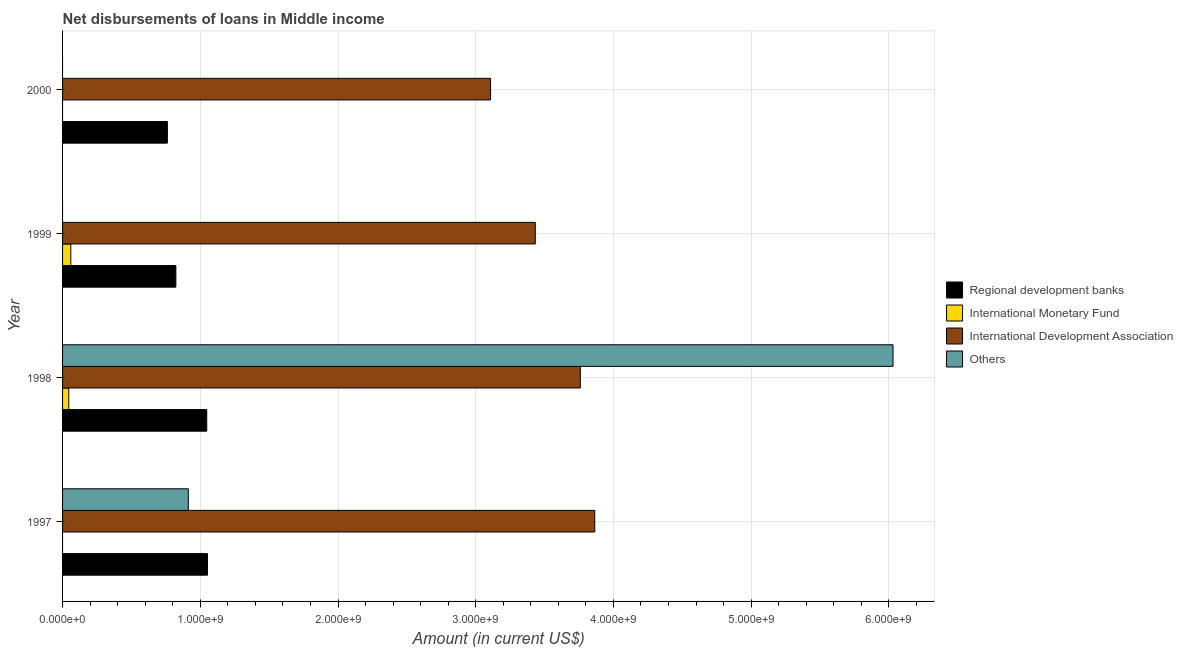How many different coloured bars are there?
Offer a very short reply. 4. How many groups of bars are there?
Provide a short and direct response. 4. Are the number of bars on each tick of the Y-axis equal?
Ensure brevity in your answer.  No. How many bars are there on the 1st tick from the top?
Your answer should be very brief. 2. What is the label of the 1st group of bars from the top?
Keep it short and to the point. 2000. What is the amount of loan disimbursed by regional development banks in 1999?
Offer a terse response. 8.23e+08. Across all years, what is the maximum amount of loan disimbursed by international development association?
Give a very brief answer. 3.86e+09. Across all years, what is the minimum amount of loan disimbursed by regional development banks?
Your answer should be compact. 7.61e+08. In which year was the amount of loan disimbursed by international monetary fund maximum?
Offer a very short reply. 1999. What is the total amount of loan disimbursed by regional development banks in the graph?
Offer a very short reply. 3.68e+09. What is the difference between the amount of loan disimbursed by regional development banks in 1999 and that in 2000?
Give a very brief answer. 6.15e+07. What is the difference between the amount of loan disimbursed by other organisations in 1997 and the amount of loan disimbursed by international development association in 1999?
Offer a very short reply. -2.52e+09. What is the average amount of loan disimbursed by other organisations per year?
Offer a very short reply. 1.74e+09. In the year 1999, what is the difference between the amount of loan disimbursed by international monetary fund and amount of loan disimbursed by regional development banks?
Keep it short and to the point. -7.63e+08. What is the ratio of the amount of loan disimbursed by regional development banks in 1997 to that in 2000?
Your answer should be very brief. 1.38. Is the amount of loan disimbursed by regional development banks in 1999 less than that in 2000?
Ensure brevity in your answer.  No. What is the difference between the highest and the second highest amount of loan disimbursed by international development association?
Your answer should be compact. 1.05e+08. What is the difference between the highest and the lowest amount of loan disimbursed by international monetary fund?
Your answer should be compact. 5.98e+07. Is the sum of the amount of loan disimbursed by regional development banks in 1997 and 1999 greater than the maximum amount of loan disimbursed by international monetary fund across all years?
Provide a short and direct response. Yes. Is it the case that in every year, the sum of the amount of loan disimbursed by regional development banks and amount of loan disimbursed by international monetary fund is greater than the amount of loan disimbursed by international development association?
Provide a short and direct response. No. Are all the bars in the graph horizontal?
Your response must be concise. Yes. How many years are there in the graph?
Your answer should be compact. 4. Are the values on the major ticks of X-axis written in scientific E-notation?
Provide a succinct answer. Yes. Does the graph contain any zero values?
Your answer should be compact. Yes. How are the legend labels stacked?
Keep it short and to the point. Vertical. What is the title of the graph?
Provide a succinct answer. Net disbursements of loans in Middle income. Does "Tracking ability" appear as one of the legend labels in the graph?
Provide a short and direct response. No. What is the label or title of the X-axis?
Ensure brevity in your answer.  Amount (in current US$). What is the Amount (in current US$) of Regional development banks in 1997?
Offer a very short reply. 1.05e+09. What is the Amount (in current US$) of International Development Association in 1997?
Your answer should be compact. 3.86e+09. What is the Amount (in current US$) in Others in 1997?
Your answer should be compact. 9.13e+08. What is the Amount (in current US$) of Regional development banks in 1998?
Ensure brevity in your answer.  1.05e+09. What is the Amount (in current US$) in International Monetary Fund in 1998?
Keep it short and to the point. 4.51e+07. What is the Amount (in current US$) of International Development Association in 1998?
Your response must be concise. 3.76e+09. What is the Amount (in current US$) of Others in 1998?
Keep it short and to the point. 6.03e+09. What is the Amount (in current US$) of Regional development banks in 1999?
Offer a very short reply. 8.23e+08. What is the Amount (in current US$) in International Monetary Fund in 1999?
Your answer should be very brief. 5.98e+07. What is the Amount (in current US$) of International Development Association in 1999?
Ensure brevity in your answer.  3.43e+09. What is the Amount (in current US$) in Regional development banks in 2000?
Offer a very short reply. 7.61e+08. What is the Amount (in current US$) in International Monetary Fund in 2000?
Your answer should be compact. 0. What is the Amount (in current US$) of International Development Association in 2000?
Ensure brevity in your answer.  3.11e+09. Across all years, what is the maximum Amount (in current US$) of Regional development banks?
Your response must be concise. 1.05e+09. Across all years, what is the maximum Amount (in current US$) of International Monetary Fund?
Offer a terse response. 5.98e+07. Across all years, what is the maximum Amount (in current US$) of International Development Association?
Provide a short and direct response. 3.86e+09. Across all years, what is the maximum Amount (in current US$) in Others?
Provide a short and direct response. 6.03e+09. Across all years, what is the minimum Amount (in current US$) of Regional development banks?
Ensure brevity in your answer.  7.61e+08. Across all years, what is the minimum Amount (in current US$) of International Monetary Fund?
Provide a succinct answer. 0. Across all years, what is the minimum Amount (in current US$) in International Development Association?
Make the answer very short. 3.11e+09. Across all years, what is the minimum Amount (in current US$) in Others?
Provide a succinct answer. 0. What is the total Amount (in current US$) in Regional development banks in the graph?
Ensure brevity in your answer.  3.68e+09. What is the total Amount (in current US$) of International Monetary Fund in the graph?
Offer a very short reply. 1.05e+08. What is the total Amount (in current US$) of International Development Association in the graph?
Make the answer very short. 1.42e+1. What is the total Amount (in current US$) of Others in the graph?
Offer a very short reply. 6.94e+09. What is the difference between the Amount (in current US$) of Regional development banks in 1997 and that in 1998?
Ensure brevity in your answer.  5.36e+06. What is the difference between the Amount (in current US$) in International Development Association in 1997 and that in 1998?
Your answer should be very brief. 1.05e+08. What is the difference between the Amount (in current US$) in Others in 1997 and that in 1998?
Provide a succinct answer. -5.12e+09. What is the difference between the Amount (in current US$) in Regional development banks in 1997 and that in 1999?
Your answer should be very brief. 2.30e+08. What is the difference between the Amount (in current US$) of International Development Association in 1997 and that in 1999?
Your response must be concise. 4.32e+08. What is the difference between the Amount (in current US$) of Regional development banks in 1997 and that in 2000?
Give a very brief answer. 2.91e+08. What is the difference between the Amount (in current US$) of International Development Association in 1997 and that in 2000?
Your answer should be very brief. 7.57e+08. What is the difference between the Amount (in current US$) of Regional development banks in 1998 and that in 1999?
Your answer should be compact. 2.24e+08. What is the difference between the Amount (in current US$) of International Monetary Fund in 1998 and that in 1999?
Give a very brief answer. -1.46e+07. What is the difference between the Amount (in current US$) of International Development Association in 1998 and that in 1999?
Offer a very short reply. 3.27e+08. What is the difference between the Amount (in current US$) in Regional development banks in 1998 and that in 2000?
Your answer should be compact. 2.86e+08. What is the difference between the Amount (in current US$) in International Development Association in 1998 and that in 2000?
Offer a very short reply. 6.52e+08. What is the difference between the Amount (in current US$) in Regional development banks in 1999 and that in 2000?
Provide a succinct answer. 6.15e+07. What is the difference between the Amount (in current US$) of International Development Association in 1999 and that in 2000?
Your answer should be very brief. 3.25e+08. What is the difference between the Amount (in current US$) of Regional development banks in 1997 and the Amount (in current US$) of International Monetary Fund in 1998?
Make the answer very short. 1.01e+09. What is the difference between the Amount (in current US$) of Regional development banks in 1997 and the Amount (in current US$) of International Development Association in 1998?
Keep it short and to the point. -2.71e+09. What is the difference between the Amount (in current US$) in Regional development banks in 1997 and the Amount (in current US$) in Others in 1998?
Give a very brief answer. -4.98e+09. What is the difference between the Amount (in current US$) of International Development Association in 1997 and the Amount (in current US$) of Others in 1998?
Provide a succinct answer. -2.17e+09. What is the difference between the Amount (in current US$) in Regional development banks in 1997 and the Amount (in current US$) in International Monetary Fund in 1999?
Your response must be concise. 9.93e+08. What is the difference between the Amount (in current US$) of Regional development banks in 1997 and the Amount (in current US$) of International Development Association in 1999?
Your answer should be very brief. -2.38e+09. What is the difference between the Amount (in current US$) in Regional development banks in 1997 and the Amount (in current US$) in International Development Association in 2000?
Provide a succinct answer. -2.06e+09. What is the difference between the Amount (in current US$) of Regional development banks in 1998 and the Amount (in current US$) of International Monetary Fund in 1999?
Your response must be concise. 9.87e+08. What is the difference between the Amount (in current US$) in Regional development banks in 1998 and the Amount (in current US$) in International Development Association in 1999?
Your response must be concise. -2.39e+09. What is the difference between the Amount (in current US$) in International Monetary Fund in 1998 and the Amount (in current US$) in International Development Association in 1999?
Provide a short and direct response. -3.39e+09. What is the difference between the Amount (in current US$) in Regional development banks in 1998 and the Amount (in current US$) in International Development Association in 2000?
Make the answer very short. -2.06e+09. What is the difference between the Amount (in current US$) of International Monetary Fund in 1998 and the Amount (in current US$) of International Development Association in 2000?
Make the answer very short. -3.06e+09. What is the difference between the Amount (in current US$) in Regional development banks in 1999 and the Amount (in current US$) in International Development Association in 2000?
Provide a succinct answer. -2.29e+09. What is the difference between the Amount (in current US$) in International Monetary Fund in 1999 and the Amount (in current US$) in International Development Association in 2000?
Keep it short and to the point. -3.05e+09. What is the average Amount (in current US$) of Regional development banks per year?
Make the answer very short. 9.21e+08. What is the average Amount (in current US$) of International Monetary Fund per year?
Give a very brief answer. 2.62e+07. What is the average Amount (in current US$) in International Development Association per year?
Your answer should be compact. 3.54e+09. What is the average Amount (in current US$) in Others per year?
Offer a terse response. 1.74e+09. In the year 1997, what is the difference between the Amount (in current US$) in Regional development banks and Amount (in current US$) in International Development Association?
Make the answer very short. -2.81e+09. In the year 1997, what is the difference between the Amount (in current US$) in Regional development banks and Amount (in current US$) in Others?
Offer a terse response. 1.39e+08. In the year 1997, what is the difference between the Amount (in current US$) of International Development Association and Amount (in current US$) of Others?
Your answer should be very brief. 2.95e+09. In the year 1998, what is the difference between the Amount (in current US$) in Regional development banks and Amount (in current US$) in International Monetary Fund?
Give a very brief answer. 1.00e+09. In the year 1998, what is the difference between the Amount (in current US$) in Regional development banks and Amount (in current US$) in International Development Association?
Offer a very short reply. -2.71e+09. In the year 1998, what is the difference between the Amount (in current US$) in Regional development banks and Amount (in current US$) in Others?
Ensure brevity in your answer.  -4.98e+09. In the year 1998, what is the difference between the Amount (in current US$) of International Monetary Fund and Amount (in current US$) of International Development Association?
Ensure brevity in your answer.  -3.71e+09. In the year 1998, what is the difference between the Amount (in current US$) in International Monetary Fund and Amount (in current US$) in Others?
Offer a terse response. -5.99e+09. In the year 1998, what is the difference between the Amount (in current US$) of International Development Association and Amount (in current US$) of Others?
Your answer should be compact. -2.27e+09. In the year 1999, what is the difference between the Amount (in current US$) of Regional development banks and Amount (in current US$) of International Monetary Fund?
Your response must be concise. 7.63e+08. In the year 1999, what is the difference between the Amount (in current US$) of Regional development banks and Amount (in current US$) of International Development Association?
Your answer should be very brief. -2.61e+09. In the year 1999, what is the difference between the Amount (in current US$) in International Monetary Fund and Amount (in current US$) in International Development Association?
Ensure brevity in your answer.  -3.37e+09. In the year 2000, what is the difference between the Amount (in current US$) in Regional development banks and Amount (in current US$) in International Development Association?
Provide a short and direct response. -2.35e+09. What is the ratio of the Amount (in current US$) in International Development Association in 1997 to that in 1998?
Keep it short and to the point. 1.03. What is the ratio of the Amount (in current US$) of Others in 1997 to that in 1998?
Your answer should be compact. 0.15. What is the ratio of the Amount (in current US$) in Regional development banks in 1997 to that in 1999?
Give a very brief answer. 1.28. What is the ratio of the Amount (in current US$) in International Development Association in 1997 to that in 1999?
Make the answer very short. 1.13. What is the ratio of the Amount (in current US$) of Regional development banks in 1997 to that in 2000?
Provide a succinct answer. 1.38. What is the ratio of the Amount (in current US$) of International Development Association in 1997 to that in 2000?
Keep it short and to the point. 1.24. What is the ratio of the Amount (in current US$) in Regional development banks in 1998 to that in 1999?
Your response must be concise. 1.27. What is the ratio of the Amount (in current US$) of International Monetary Fund in 1998 to that in 1999?
Make the answer very short. 0.76. What is the ratio of the Amount (in current US$) in International Development Association in 1998 to that in 1999?
Your answer should be very brief. 1.1. What is the ratio of the Amount (in current US$) of Regional development banks in 1998 to that in 2000?
Give a very brief answer. 1.38. What is the ratio of the Amount (in current US$) in International Development Association in 1998 to that in 2000?
Keep it short and to the point. 1.21. What is the ratio of the Amount (in current US$) in Regional development banks in 1999 to that in 2000?
Offer a terse response. 1.08. What is the ratio of the Amount (in current US$) of International Development Association in 1999 to that in 2000?
Provide a short and direct response. 1.1. What is the difference between the highest and the second highest Amount (in current US$) in Regional development banks?
Your response must be concise. 5.36e+06. What is the difference between the highest and the second highest Amount (in current US$) of International Development Association?
Your answer should be compact. 1.05e+08. What is the difference between the highest and the lowest Amount (in current US$) of Regional development banks?
Provide a short and direct response. 2.91e+08. What is the difference between the highest and the lowest Amount (in current US$) in International Monetary Fund?
Keep it short and to the point. 5.98e+07. What is the difference between the highest and the lowest Amount (in current US$) in International Development Association?
Provide a succinct answer. 7.57e+08. What is the difference between the highest and the lowest Amount (in current US$) in Others?
Your answer should be compact. 6.03e+09. 